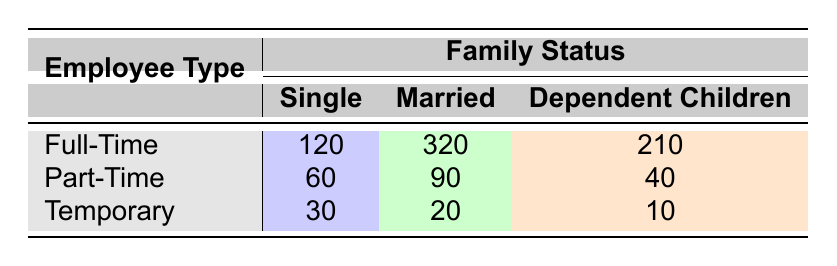What is the health benefits utilization for Full-Time employees with Dependents? The health benefits utilization for Full-Time employees with Dependents Children can be found in the corresponding cell under the "Full-Time" row and "Dependent Children" column. The value is 210.
Answer: 210 Which family status has the highest health benefits utilization among Part-Time workers? To find the family status with the highest utilization among Part-Time workers, compare the values in the Part-Time row: Single (60), Married (90), and Dependent Children (40). The highest is 90 for Married.
Answer: Married Is the health benefits utilization higher for Full-Time employees than for Temporary employees in the Married category? The health benefits utilization for Full-Time employees with Married status is 320, while for Temporary employees it is 20. Since 320 is greater than 20, the answer is yes.
Answer: Yes What is the total health benefits utilization for all Temporary employees combined? To calculate the total for Temporary employees, sum the values from the Temporary row: Single (30), Married (20), and Dependent Children (10). The total is 30 + 20 + 10 = 60.
Answer: 60 Which employee type and family status combination has the lowest health benefits utilization? By examining the table, among all combinations the lowest utilization is found in the Temporary employee group under the "Dependent Children" status with a value of 10.
Answer: Temporary/Dependent Children What is the average health benefits utilization for Full-Time employees? To find the average for Full-Time employees, sum the values: Single (120), Married (320), and Dependent Children (210), which results in 120 + 320 + 210 = 650. Since there are three categories, the average is 650 / 3 = approximately 216.67.
Answer: 216.67 True or False: The health benefits utilization for Single Part-Time employees is equal to that of Temporary employees with Married status. The utilization for Single Part-Time employees is 60, while for Temporary employees with Married status it is 20. Since 60 is not equal to 20, the statement is false.
Answer: False How much more utilization do Full-Time employees with Dependents have compared to Temporary employees with the same status? The utilization for Full-Time employees with Dependent Children is 210 and for Temporary employees with the same status is 10. The difference is 210 - 10 = 200.
Answer: 200 